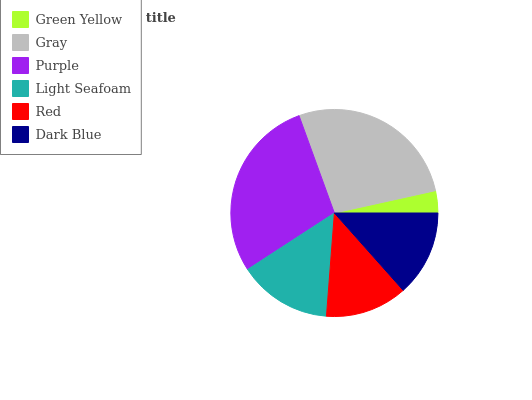Is Green Yellow the minimum?
Answer yes or no. Yes. Is Purple the maximum?
Answer yes or no. Yes. Is Gray the minimum?
Answer yes or no. No. Is Gray the maximum?
Answer yes or no. No. Is Gray greater than Green Yellow?
Answer yes or no. Yes. Is Green Yellow less than Gray?
Answer yes or no. Yes. Is Green Yellow greater than Gray?
Answer yes or no. No. Is Gray less than Green Yellow?
Answer yes or no. No. Is Light Seafoam the high median?
Answer yes or no. Yes. Is Dark Blue the low median?
Answer yes or no. Yes. Is Green Yellow the high median?
Answer yes or no. No. Is Red the low median?
Answer yes or no. No. 